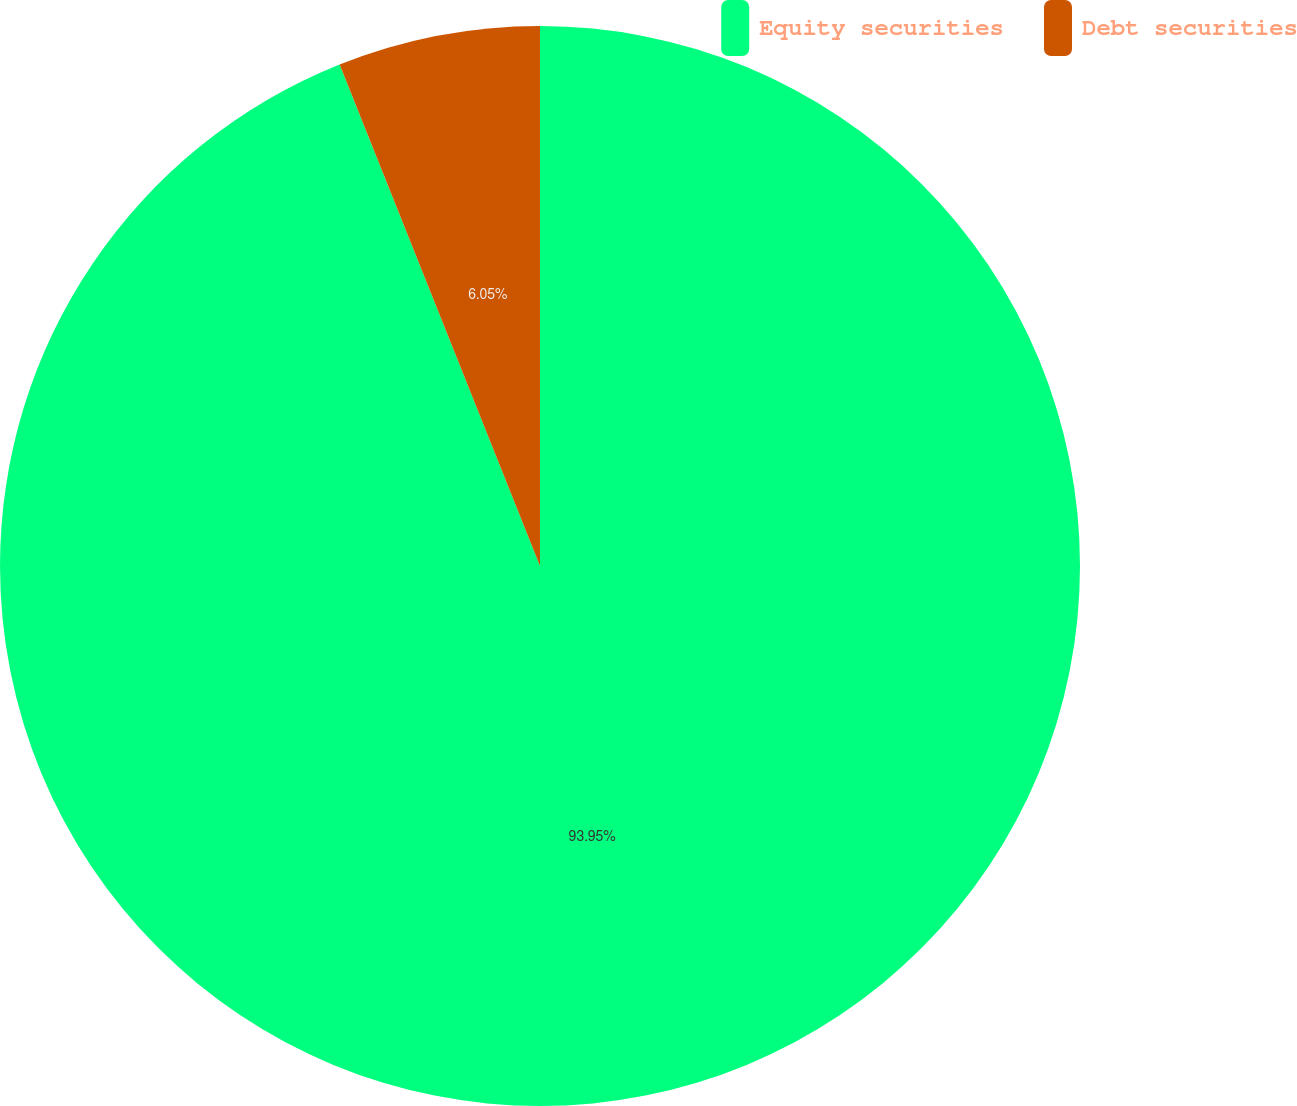Convert chart to OTSL. <chart><loc_0><loc_0><loc_500><loc_500><pie_chart><fcel>Equity securities<fcel>Debt securities<nl><fcel>93.95%<fcel>6.05%<nl></chart> 